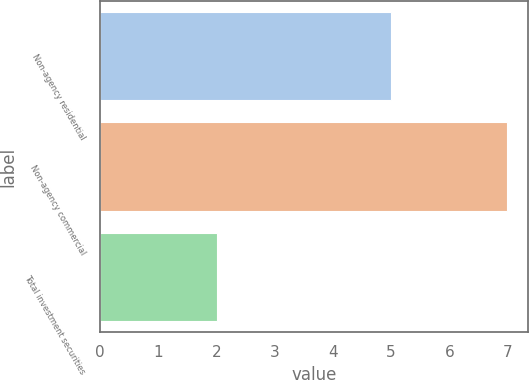<chart> <loc_0><loc_0><loc_500><loc_500><bar_chart><fcel>Non-agency residential<fcel>Non-agency commercial<fcel>Total investment securities<nl><fcel>5<fcel>7<fcel>2<nl></chart> 